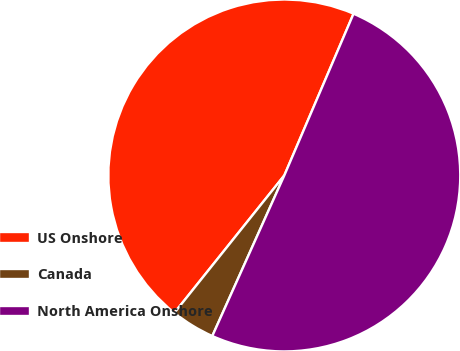Convert chart to OTSL. <chart><loc_0><loc_0><loc_500><loc_500><pie_chart><fcel>US Onshore<fcel>Canada<fcel>North America Onshore<nl><fcel>45.7%<fcel>4.03%<fcel>50.27%<nl></chart> 